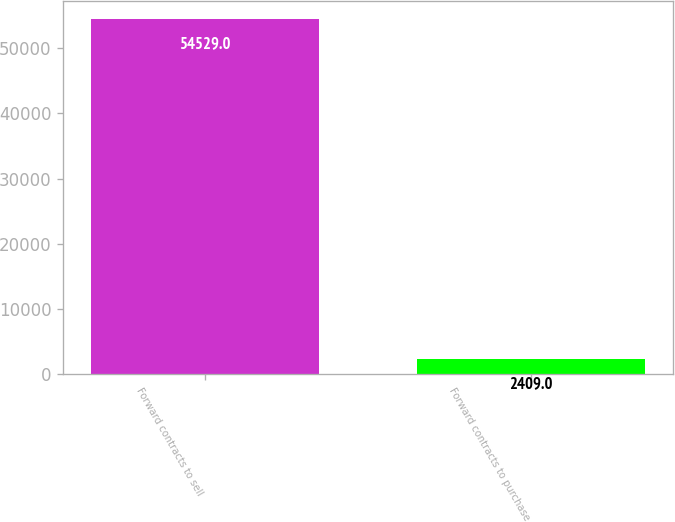Convert chart. <chart><loc_0><loc_0><loc_500><loc_500><bar_chart><fcel>Forward contracts to sell<fcel>Forward contracts to purchase<nl><fcel>54529<fcel>2409<nl></chart> 